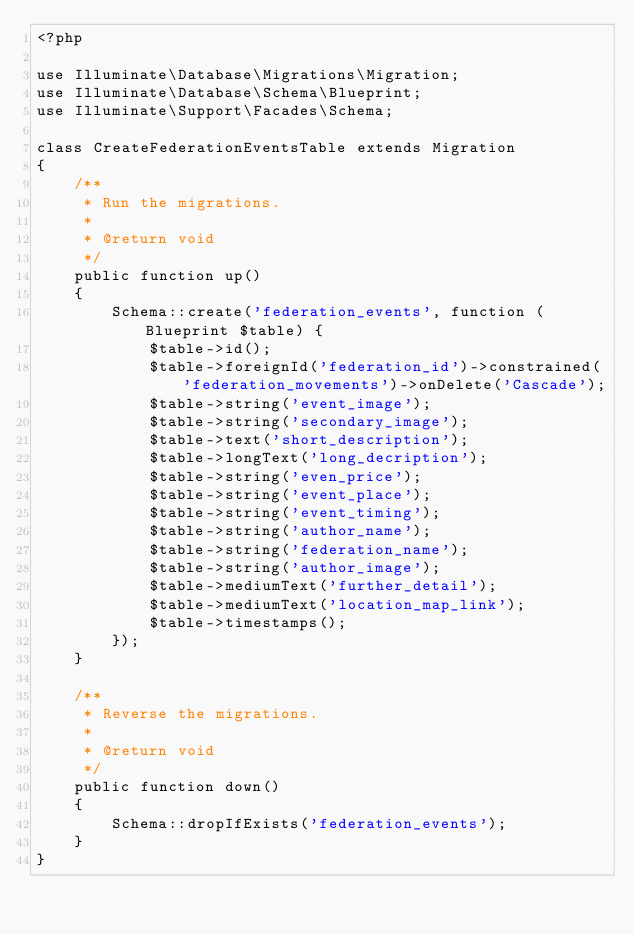Convert code to text. <code><loc_0><loc_0><loc_500><loc_500><_PHP_><?php

use Illuminate\Database\Migrations\Migration;
use Illuminate\Database\Schema\Blueprint;
use Illuminate\Support\Facades\Schema;

class CreateFederationEventsTable extends Migration
{
    /**
     * Run the migrations.
     *
     * @return void
     */
    public function up()
    {
        Schema::create('federation_events', function (Blueprint $table) {
            $table->id();
            $table->foreignId('federation_id')->constrained('federation_movements')->onDelete('Cascade');
            $table->string('event_image');
            $table->string('secondary_image');
            $table->text('short_description');
            $table->longText('long_decription');
            $table->string('even_price');
            $table->string('event_place');
            $table->string('event_timing');
            $table->string('author_name');
            $table->string('federation_name');
            $table->string('author_image');
            $table->mediumText('further_detail');
            $table->mediumText('location_map_link');
            $table->timestamps();
        });
    }

    /**
     * Reverse the migrations.
     *
     * @return void
     */
    public function down()
    {
        Schema::dropIfExists('federation_events');
    }
}
</code> 